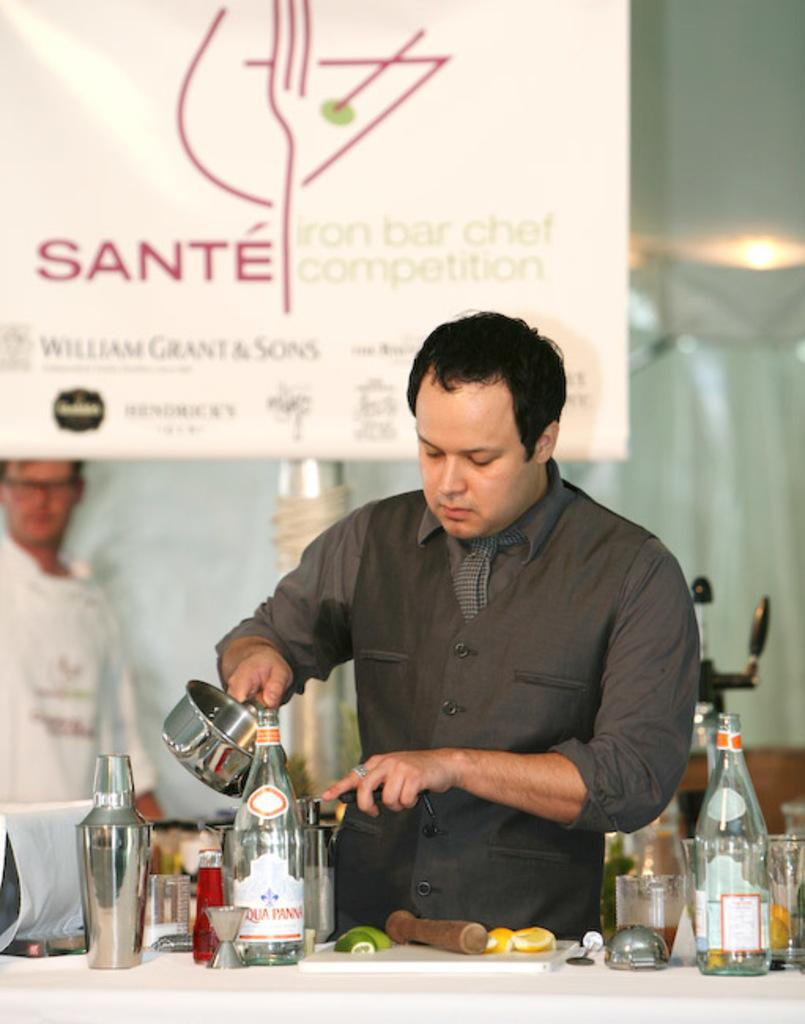<image>
Create a compact narrative representing the image presented. A man at the Sante bar and chef competition making a drink. 